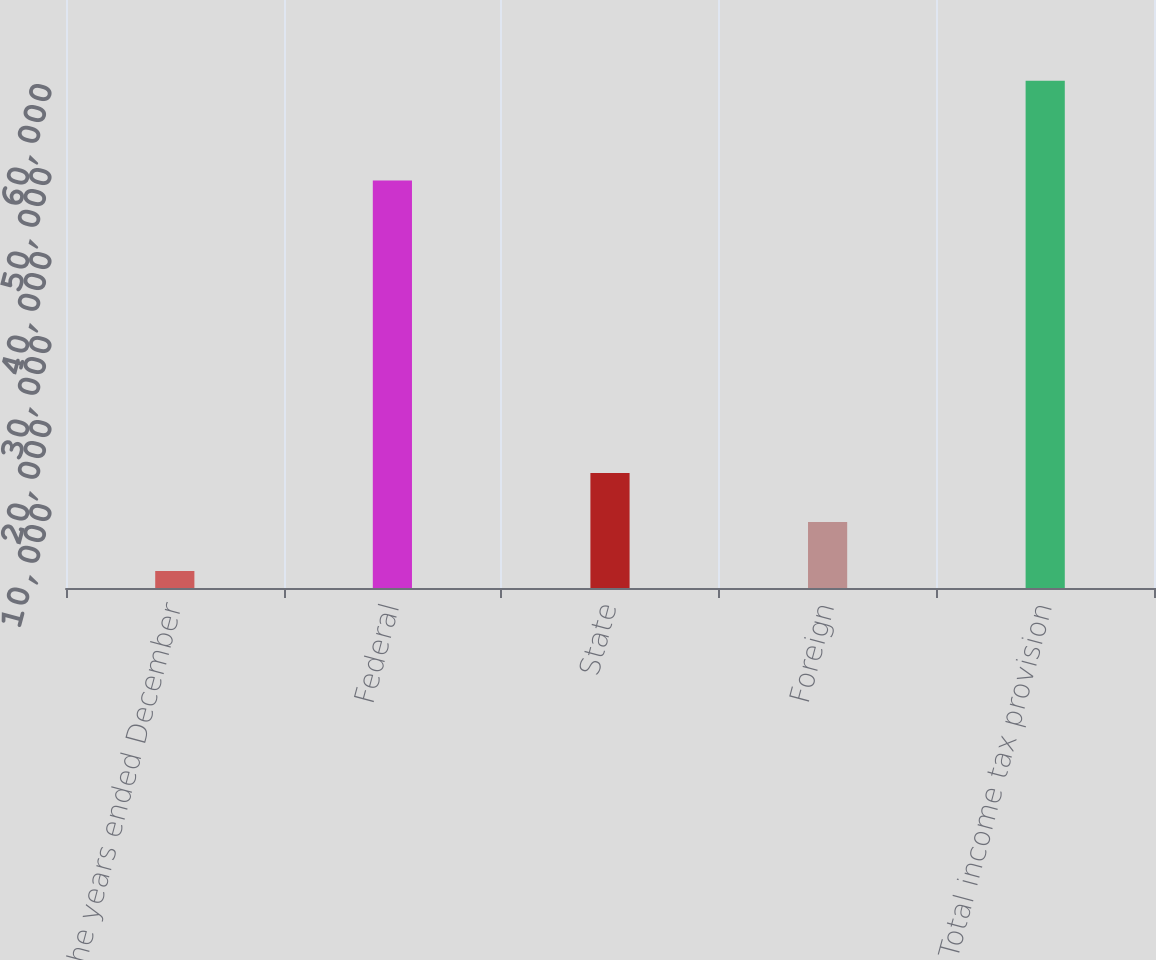Convert chart. <chart><loc_0><loc_0><loc_500><loc_500><bar_chart><fcel>For the years ended December<fcel>Federal<fcel>State<fcel>Foreign<fcel>Total income tax provision<nl><fcel>2011<fcel>48505<fcel>13685.8<fcel>7848.4<fcel>60385<nl></chart> 